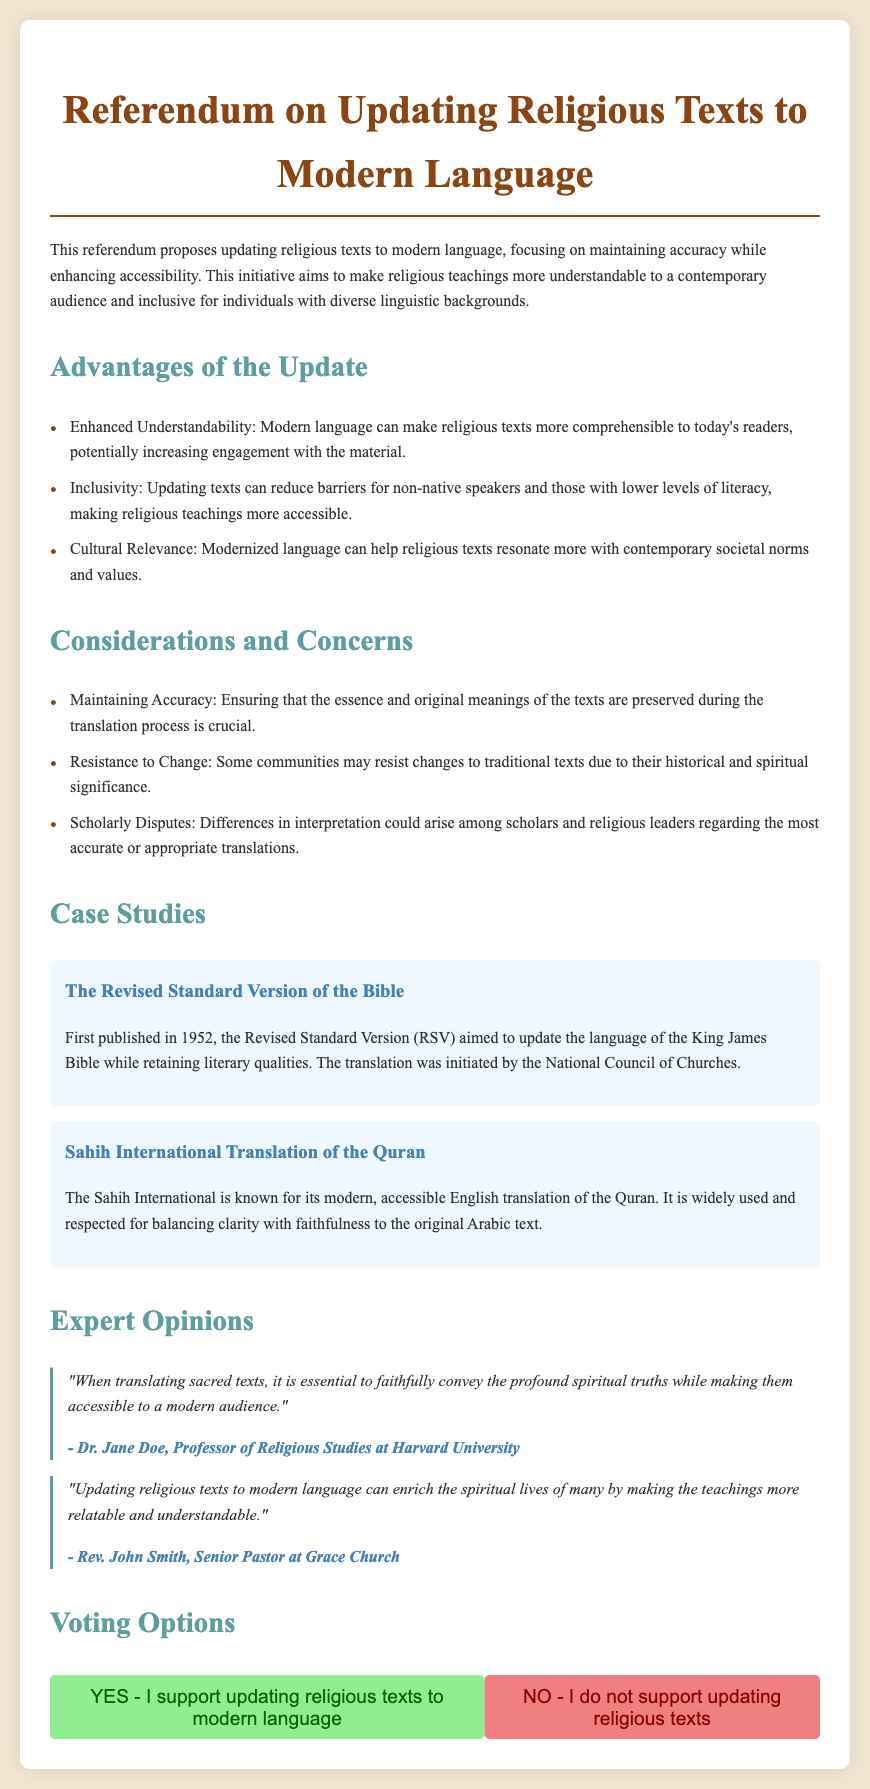What is the title of the referendum? The title of the referendum is found at the top of the document.
Answer: Referendum on Updating Religious Texts to Modern Language What is one advantage of updating religious texts? The document lists advantages, one of which is enhancing understandability.
Answer: Enhanced Understandability What is a concern mentioned in the document? The document lists several concerns, one of which is maintaining accuracy.
Answer: Maintaining Accuracy Who initiated the Revised Standard Version of the Bible? The document specifies the organization that initiated this translation.
Answer: National Council of Churches What year was the Revised Standard Version first published? The year of publication is mentioned in the case study section.
Answer: 1952 Which translation is known for being accessible? The document describes specific translations, one of which is known for its modern and accessible nature.
Answer: Sahih International Who is the author of the quote about translating sacred texts? The document attributes the quote to a specific individual in religious studies.
Answer: Dr. Jane Doe What are the voting options provided? The document presents two clear voting options regarding the referendum.
Answer: YES and NO 